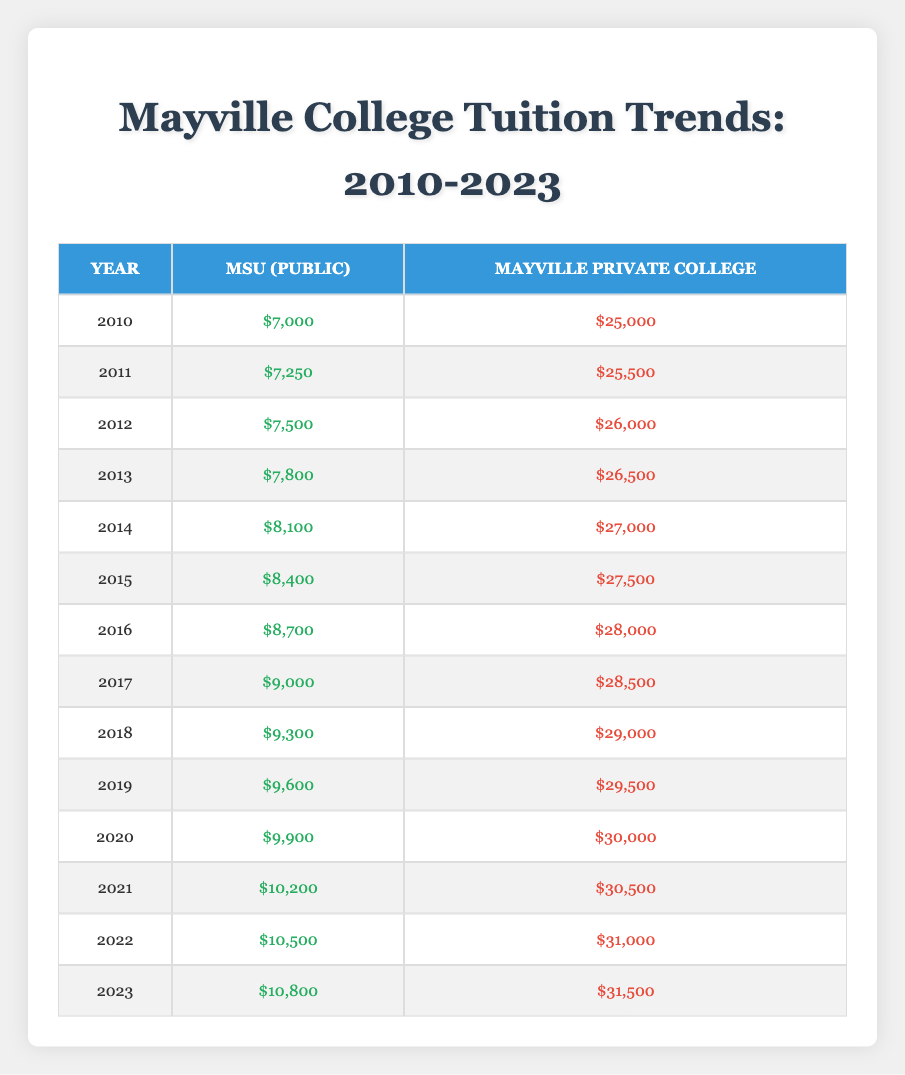What was the tuition fee for MSU in 2015? The tuition fee for MSU in 2015 is found directly in the table under the corresponding year. The value listed for that year is $8,400.
Answer: $8,400 What is the tuition fee difference between MSU and Mayville Private College in 2022? To determine the difference, we need to find both tuition fees from the table for the year 2022. MSU's tuition is $10,500 and Mayville Private College's tuition is $31,000. The difference is calculated as $31,000 - $10,500 = $20,500.
Answer: $20,500 Is the tuition for Mayville Private College higher than MSU in 2013? We check the tuition fees for both schools in 2013 from the table. MSU's tuition is $7,800 and Mayville Private College's tuition is $26,500. Since $26,500 > $7,800, the statement is true.
Answer: Yes What was the average tuition fee for MSU from 2010 to 2013? To find the average, we first sum the tuition fees for each year from 2010 to 2013: $7,000 + $7,250 + $7,500 + $7,800 = $29,550. Since there are 4 years, we divide the total by 4: $29,550 / 4 = $7,387.50.
Answer: $7,387.50 Did the tuition fees for MSU increase every year from 2010 to 2023? We need to verify the tuition fees for each year from 2010 to 2023. Reviewing the table, it shows that each year's tuition is higher than the previous year. Therefore, the statement is true.
Answer: Yes What is the total tuition fee increase of Mayville Private College from 2010 to 2023? To calculate the total increase, we take the tuition fee of Mayville Private College in 2023 ($31,500) and subtract that of 2010 ($25,000): $31,500 - $25,000 = $6,500.
Answer: $6,500 In which year did the tuition for MSU first exceed $10,000? Referring to the table, we look for the first year where MSU's tuition crosses $10,000. The tuition exceeds $10,000 for the first time in 2021, when it is $10,200.
Answer: 2021 What was the tuition fee for Mayville Private College in 2019? The tuition fee for Mayville Private College in 2019 can be directly found from the table. The value for that year is $29,500.
Answer: $29,500 